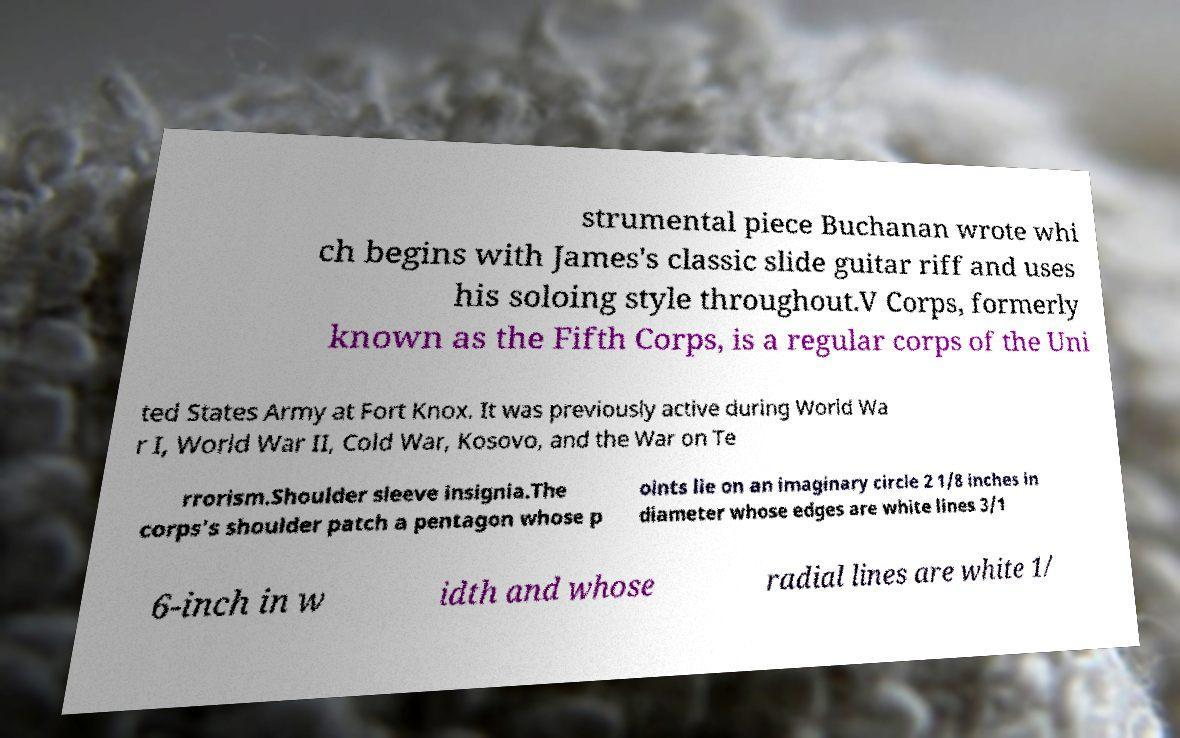Please read and relay the text visible in this image. What does it say? strumental piece Buchanan wrote whi ch begins with James's classic slide guitar riff and uses his soloing style throughout.V Corps, formerly known as the Fifth Corps, is a regular corps of the Uni ted States Army at Fort Knox. It was previously active during World Wa r I, World War II, Cold War, Kosovo, and the War on Te rrorism.Shoulder sleeve insignia.The corps's shoulder patch a pentagon whose p oints lie on an imaginary circle 2 1/8 inches in diameter whose edges are white lines 3/1 6-inch in w idth and whose radial lines are white 1/ 